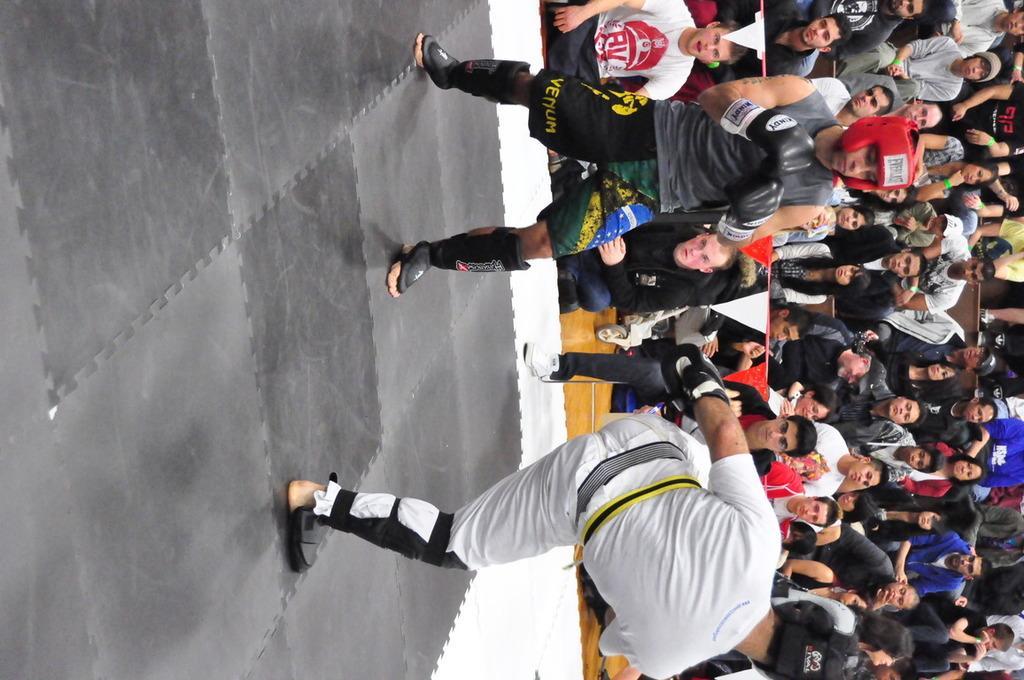Could you give a brief overview of what you see in this image? In this image I can see two persons wearing black and white colored dresses are standing in the boxing ring. In the background I can see number of persons sitting and standing. I can see few red and white colored flags. 